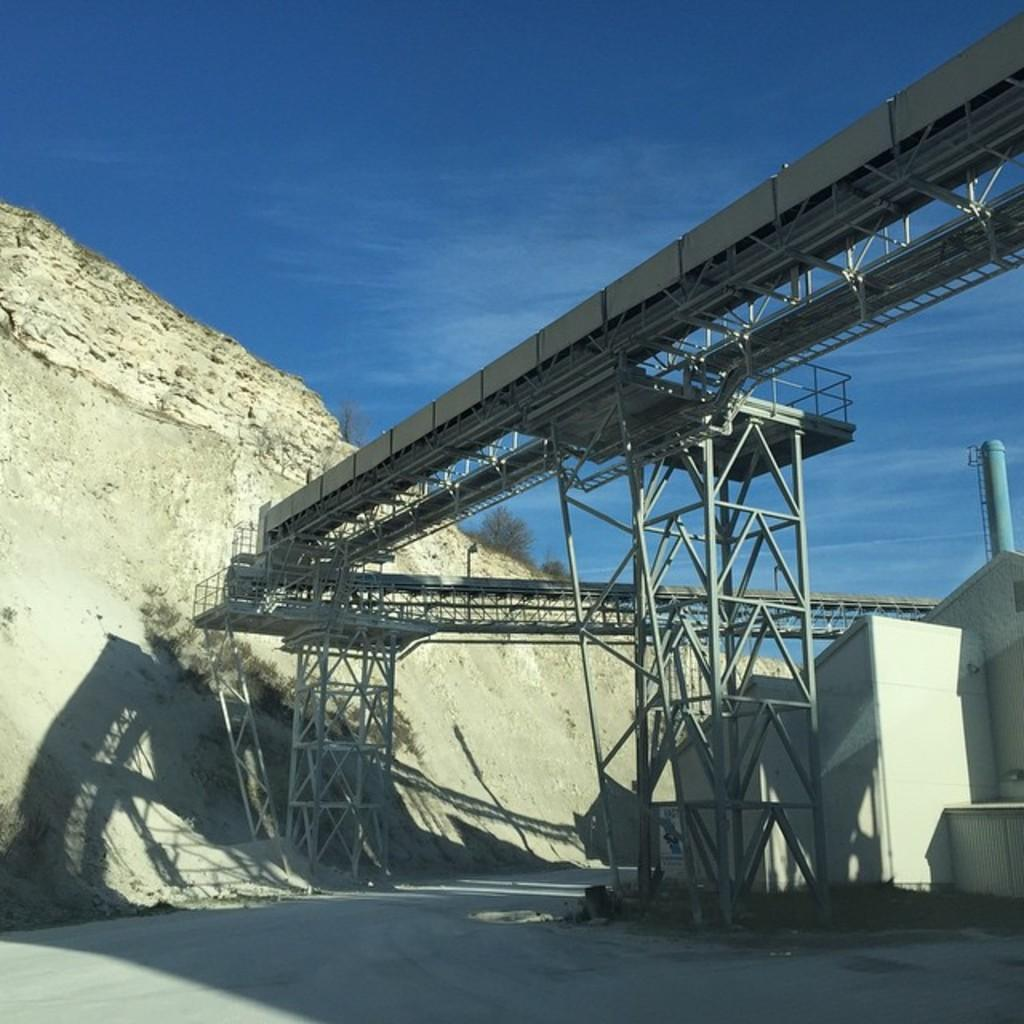What is the main subject in the center of the image? There is an architecture in the center of the image. How many knives are used to create the curve in the architecture? There is no mention of knives or curves in the architecture in the image, so it is not possible to answer that question. 